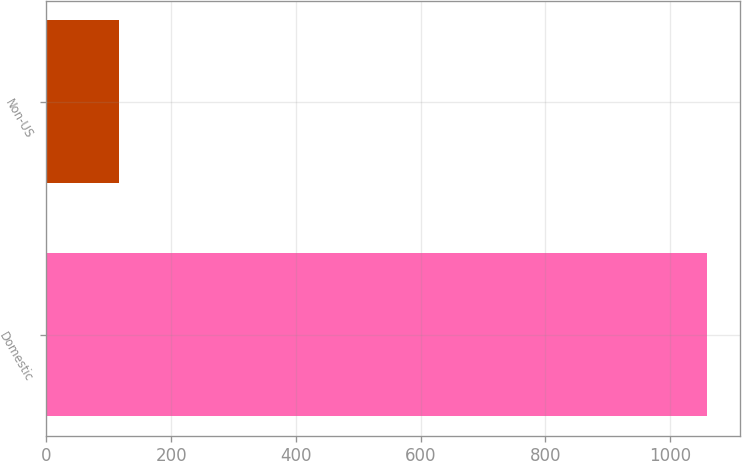<chart> <loc_0><loc_0><loc_500><loc_500><bar_chart><fcel>Domestic<fcel>Non-US<nl><fcel>1059.1<fcel>116.3<nl></chart> 